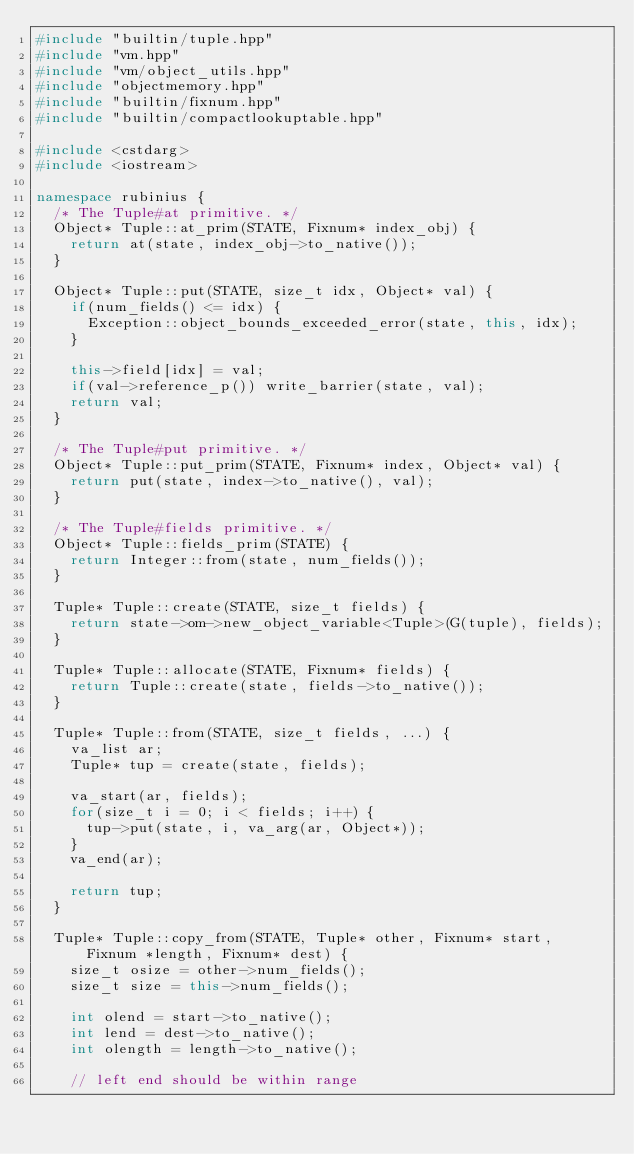<code> <loc_0><loc_0><loc_500><loc_500><_C++_>#include "builtin/tuple.hpp"
#include "vm.hpp"
#include "vm/object_utils.hpp"
#include "objectmemory.hpp"
#include "builtin/fixnum.hpp"
#include "builtin/compactlookuptable.hpp"

#include <cstdarg>
#include <iostream>

namespace rubinius {
  /* The Tuple#at primitive. */
  Object* Tuple::at_prim(STATE, Fixnum* index_obj) {
    return at(state, index_obj->to_native());
  }

  Object* Tuple::put(STATE, size_t idx, Object* val) {
    if(num_fields() <= idx) {
      Exception::object_bounds_exceeded_error(state, this, idx);
    }

    this->field[idx] = val;
    if(val->reference_p()) write_barrier(state, val);
    return val;
  }

  /* The Tuple#put primitive. */
  Object* Tuple::put_prim(STATE, Fixnum* index, Object* val) {
    return put(state, index->to_native(), val);
  }

  /* The Tuple#fields primitive. */
  Object* Tuple::fields_prim(STATE) {
    return Integer::from(state, num_fields());
  }

  Tuple* Tuple::create(STATE, size_t fields) {
    return state->om->new_object_variable<Tuple>(G(tuple), fields);
  }

  Tuple* Tuple::allocate(STATE, Fixnum* fields) {
    return Tuple::create(state, fields->to_native());
  }

  Tuple* Tuple::from(STATE, size_t fields, ...) {
    va_list ar;
    Tuple* tup = create(state, fields);

    va_start(ar, fields);
    for(size_t i = 0; i < fields; i++) {
      tup->put(state, i, va_arg(ar, Object*));
    }
    va_end(ar);

    return tup;
  }

  Tuple* Tuple::copy_from(STATE, Tuple* other, Fixnum* start, Fixnum *length, Fixnum* dest) {
    size_t osize = other->num_fields();
    size_t size = this->num_fields();

    int olend = start->to_native();
    int lend = dest->to_native();
    int olength = length->to_native();

    // left end should be within range</code> 